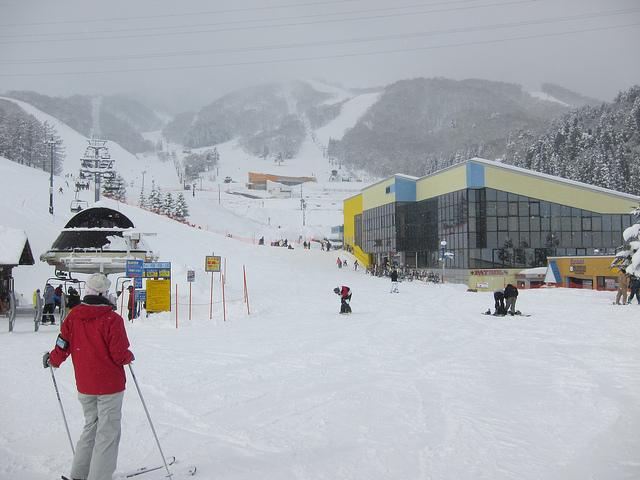What are the people going to do?
Be succinct. Ski. What season is it?
Short answer required. Winter. What color is his jacket?
Be succinct. Red. 